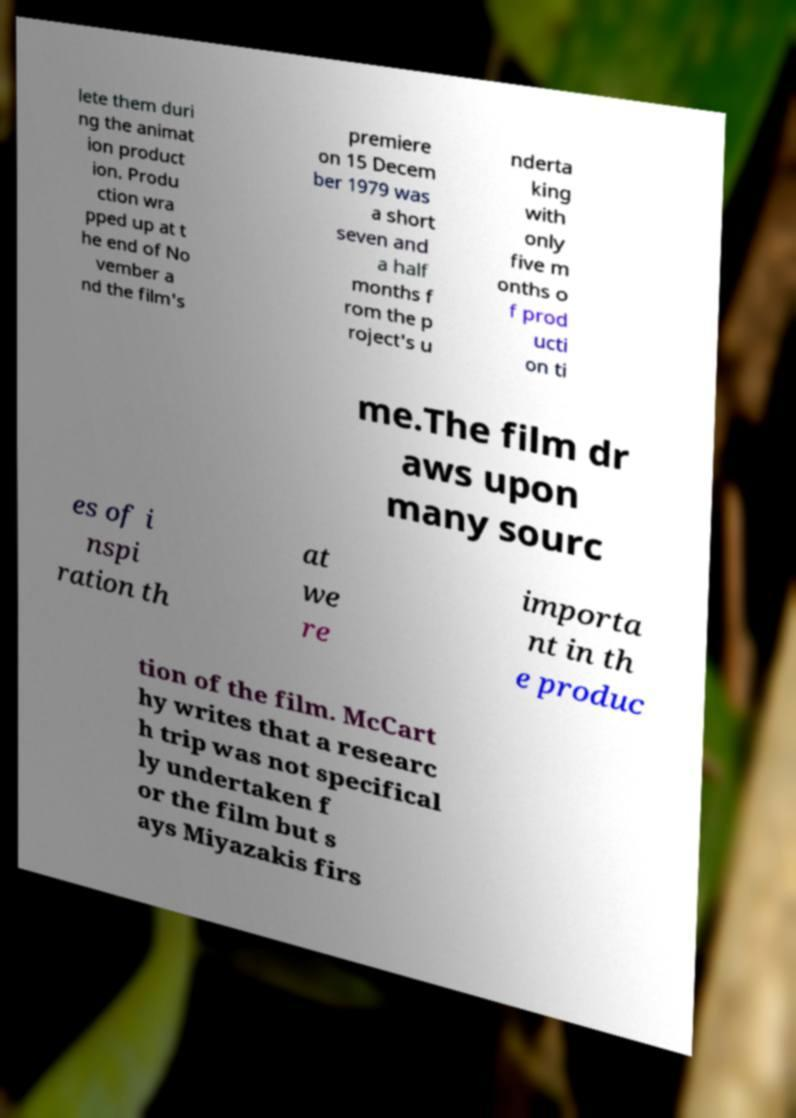Can you read and provide the text displayed in the image?This photo seems to have some interesting text. Can you extract and type it out for me? lete them duri ng the animat ion product ion. Produ ction wra pped up at t he end of No vember a nd the film's premiere on 15 Decem ber 1979 was a short seven and a half months f rom the p roject's u nderta king with only five m onths o f prod ucti on ti me.The film dr aws upon many sourc es of i nspi ration th at we re importa nt in th e produc tion of the film. McCart hy writes that a researc h trip was not specifical ly undertaken f or the film but s ays Miyazakis firs 